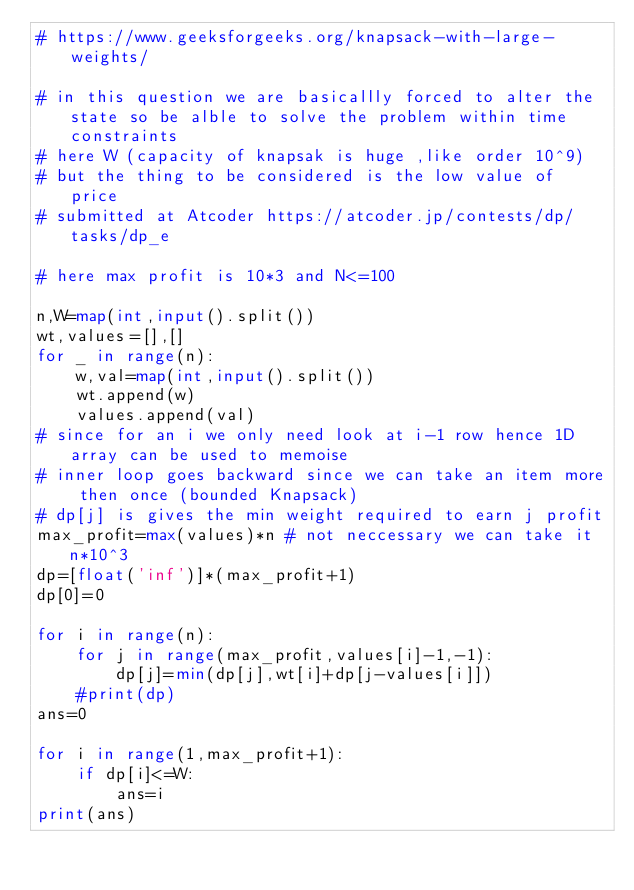<code> <loc_0><loc_0><loc_500><loc_500><_Python_># https://www.geeksforgeeks.org/knapsack-with-large-weights/

# in this question we are basicallly forced to alter the state so be alble to solve the problem within time constraints
# here W (capacity of knapsak is huge ,like order 10^9)
# but the thing to be considered is the low value of price
# submitted at Atcoder https://atcoder.jp/contests/dp/tasks/dp_e

# here max profit is 10*3 and N<=100

n,W=map(int,input().split())
wt,values=[],[]
for _ in range(n):
    w,val=map(int,input().split())
    wt.append(w)
    values.append(val)
# since for an i we only need look at i-1 row hence 1D array can be used to memoise
# inner loop goes backward since we can take an item more then once (bounded Knapsack)
# dp[j] is gives the min weight required to earn j profit
max_profit=max(values)*n # not neccessary we can take it n*10^3
dp=[float('inf')]*(max_profit+1)
dp[0]=0

for i in range(n):
    for j in range(max_profit,values[i]-1,-1):
        dp[j]=min(dp[j],wt[i]+dp[j-values[i]])
    #print(dp)
ans=0

for i in range(1,max_profit+1):
    if dp[i]<=W:
        ans=i
print(ans)
    





</code> 